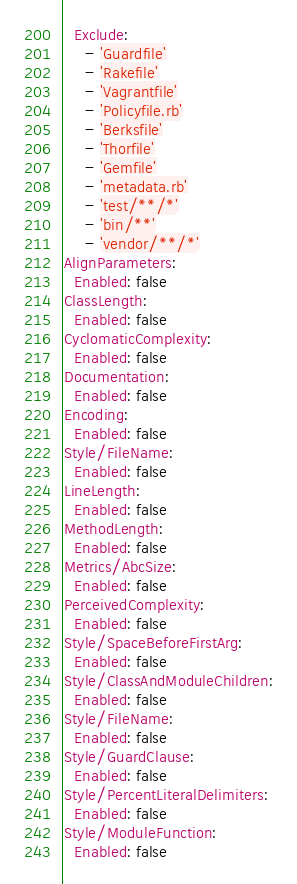Convert code to text. <code><loc_0><loc_0><loc_500><loc_500><_YAML_>  Exclude:
    - 'Guardfile'
    - 'Rakefile'
    - 'Vagrantfile'
    - 'Policyfile.rb'
    - 'Berksfile'
    - 'Thorfile'
    - 'Gemfile'
    - 'metadata.rb'
    - 'test/**/*'
    - 'bin/**'
    - 'vendor/**/*'
AlignParameters:
  Enabled: false
ClassLength:
  Enabled: false
CyclomaticComplexity:
  Enabled: false
Documentation:
  Enabled: false
Encoding:
  Enabled: false
Style/FileName:
  Enabled: false
LineLength:
  Enabled: false
MethodLength:
  Enabled: false
Metrics/AbcSize:
  Enabled: false
PerceivedComplexity:
  Enabled: false
Style/SpaceBeforeFirstArg:
  Enabled: false
Style/ClassAndModuleChildren:
  Enabled: false
Style/FileName:
  Enabled: false
Style/GuardClause:
  Enabled: false
Style/PercentLiteralDelimiters:
  Enabled: false
Style/ModuleFunction:
  Enabled: false
</code> 